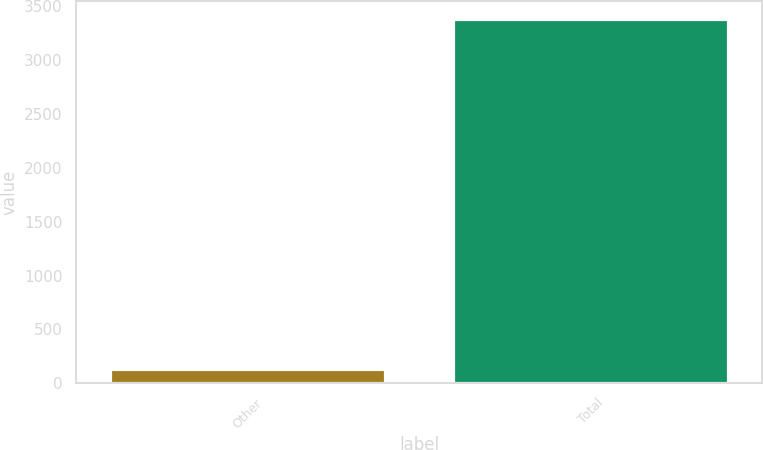<chart> <loc_0><loc_0><loc_500><loc_500><bar_chart><fcel>Other<fcel>Total<nl><fcel>129<fcel>3380<nl></chart> 